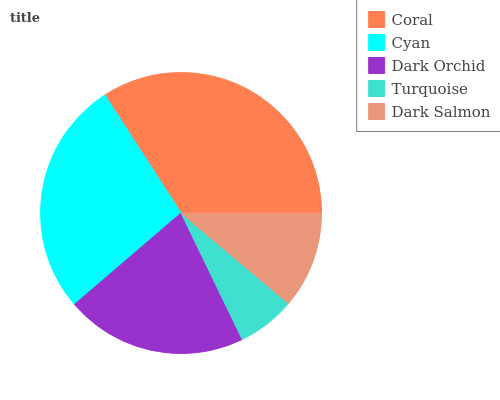Is Turquoise the minimum?
Answer yes or no. Yes. Is Coral the maximum?
Answer yes or no. Yes. Is Cyan the minimum?
Answer yes or no. No. Is Cyan the maximum?
Answer yes or no. No. Is Coral greater than Cyan?
Answer yes or no. Yes. Is Cyan less than Coral?
Answer yes or no. Yes. Is Cyan greater than Coral?
Answer yes or no. No. Is Coral less than Cyan?
Answer yes or no. No. Is Dark Orchid the high median?
Answer yes or no. Yes. Is Dark Orchid the low median?
Answer yes or no. Yes. Is Coral the high median?
Answer yes or no. No. Is Coral the low median?
Answer yes or no. No. 